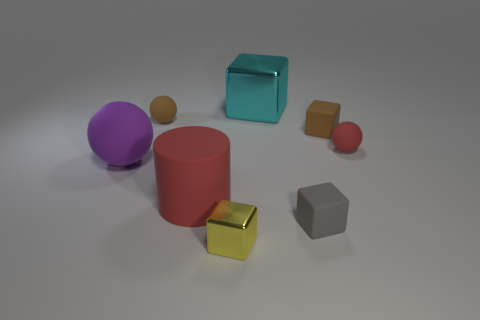Is there anything else that is the same color as the matte cylinder?
Offer a very short reply. Yes. How big is the shiny cube in front of the small rubber cube behind the big matte object that is to the left of the rubber cylinder?
Keep it short and to the point. Small. What color is the thing that is both behind the tiny brown block and to the left of the large red object?
Provide a short and direct response. Brown. There is a metal cube right of the small metal cube; how big is it?
Ensure brevity in your answer.  Large. How many purple cylinders have the same material as the yellow object?
Your response must be concise. 0. The rubber object that is the same color as the matte cylinder is what shape?
Give a very brief answer. Sphere. Do the small matte thing that is in front of the large purple rubber object and the cyan metallic thing have the same shape?
Your response must be concise. Yes. The small thing that is made of the same material as the cyan cube is what color?
Your response must be concise. Yellow. There is a red thing in front of the big purple ball that is behind the small gray matte object; is there a large rubber ball that is right of it?
Your answer should be very brief. No. The small red rubber object is what shape?
Give a very brief answer. Sphere. 